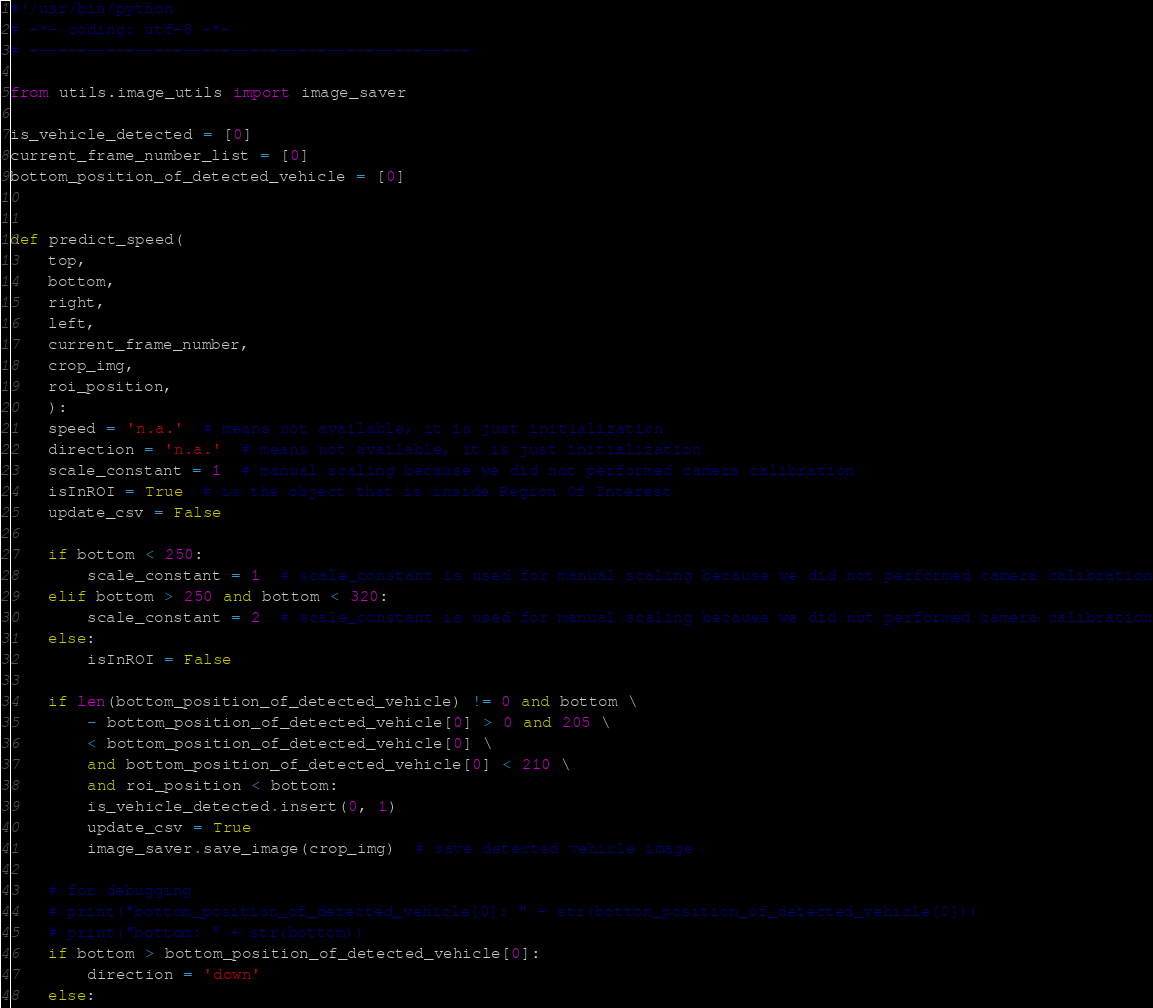Convert code to text. <code><loc_0><loc_0><loc_500><loc_500><_Python_>#!/usr/bin/python
# -*- coding: utf-8 -*-
# ----------------------------------------------

from utils.image_utils import image_saver

is_vehicle_detected = [0]
current_frame_number_list = [0]
bottom_position_of_detected_vehicle = [0]


def predict_speed(
    top,
    bottom,
    right,
    left,
    current_frame_number,
    crop_img,
    roi_position,
    ):
    speed = 'n.a.'  # means not available, it is just initialization
    direction = 'n.a.'  # means not available, it is just initialization
    scale_constant = 1  # manual scaling because we did not performed camera calibration
    isInROI = True  # is the object that is inside Region Of Interest
    update_csv = False

    if bottom < 250:
        scale_constant = 1  # scale_constant is used for manual scaling because we did not performed camera calibration
    elif bottom > 250 and bottom < 320:
        scale_constant = 2  # scale_constant is used for manual scaling because we did not performed camera calibration
    else:
        isInROI = False

    if len(bottom_position_of_detected_vehicle) != 0 and bottom \
        - bottom_position_of_detected_vehicle[0] > 0 and 205 \
        < bottom_position_of_detected_vehicle[0] \
        and bottom_position_of_detected_vehicle[0] < 210 \
        and roi_position < bottom:
        is_vehicle_detected.insert(0, 1)
        update_csv = True
        image_saver.save_image(crop_img)  # save detected vehicle image

    # for debugging
    # print("bottom_position_of_detected_vehicle[0]: " + str(bottom_position_of_detected_vehicle[0]))
    # print("bottom: " + str(bottom))
    if bottom > bottom_position_of_detected_vehicle[0]:
        direction = 'down'
    else:</code> 